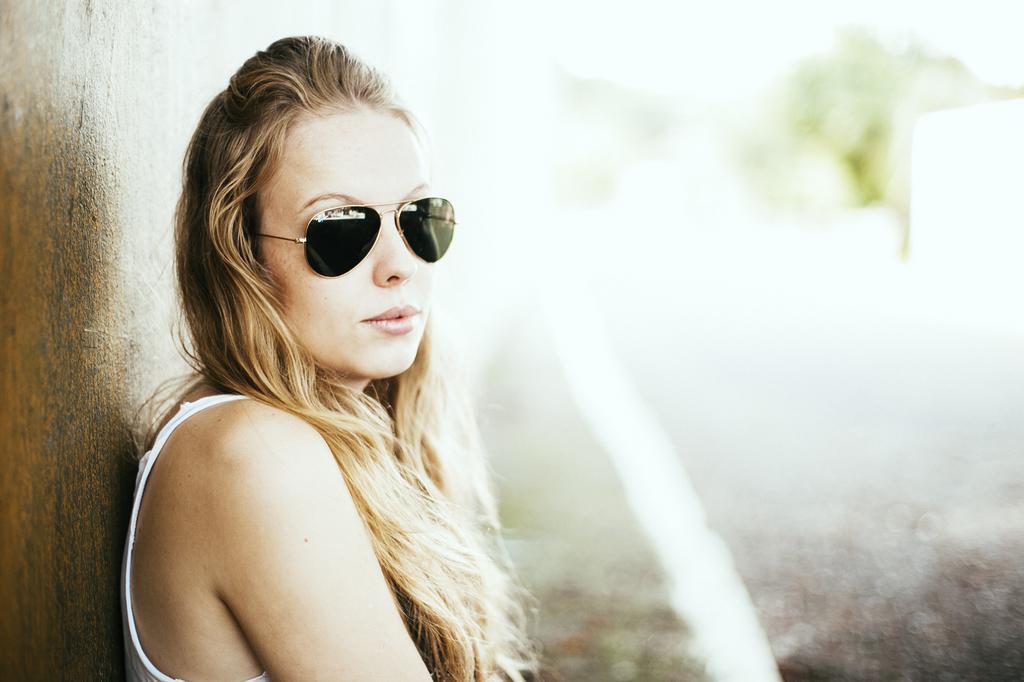Can you describe this image briefly? In the image we can see a woman wearing clothes and google. This is a wall and the background is blurred. 